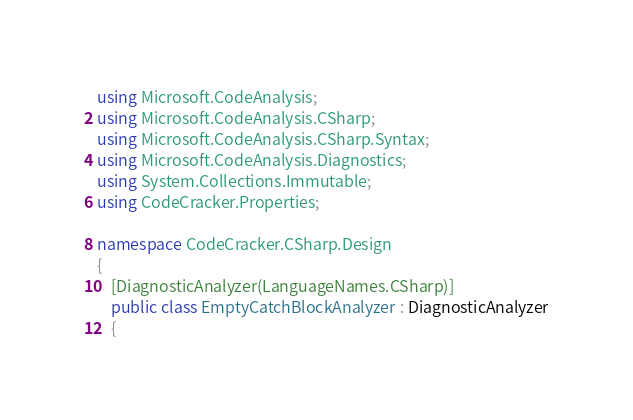<code> <loc_0><loc_0><loc_500><loc_500><_C#_>using Microsoft.CodeAnalysis;
using Microsoft.CodeAnalysis.CSharp;
using Microsoft.CodeAnalysis.CSharp.Syntax;
using Microsoft.CodeAnalysis.Diagnostics;
using System.Collections.Immutable;
using CodeCracker.Properties;

namespace CodeCracker.CSharp.Design
{
    [DiagnosticAnalyzer(LanguageNames.CSharp)]
    public class EmptyCatchBlockAnalyzer : DiagnosticAnalyzer
    {</code> 